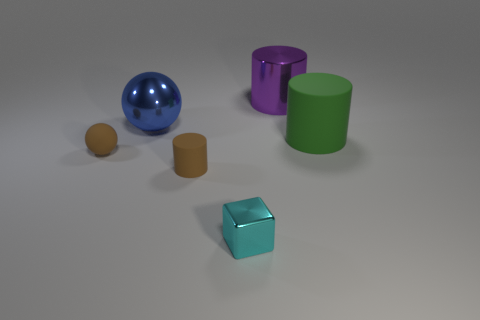Add 4 big red spheres. How many objects exist? 10 Subtract all tiny brown rubber cylinders. How many cylinders are left? 2 Subtract 1 cylinders. How many cylinders are left? 2 Subtract all spheres. How many objects are left? 4 Add 3 cyan blocks. How many cyan blocks are left? 4 Add 4 small brown matte cylinders. How many small brown matte cylinders exist? 5 Subtract 0 green cubes. How many objects are left? 6 Subtract all gray cylinders. Subtract all purple balls. How many cylinders are left? 3 Subtract all large red rubber blocks. Subtract all large metal balls. How many objects are left? 5 